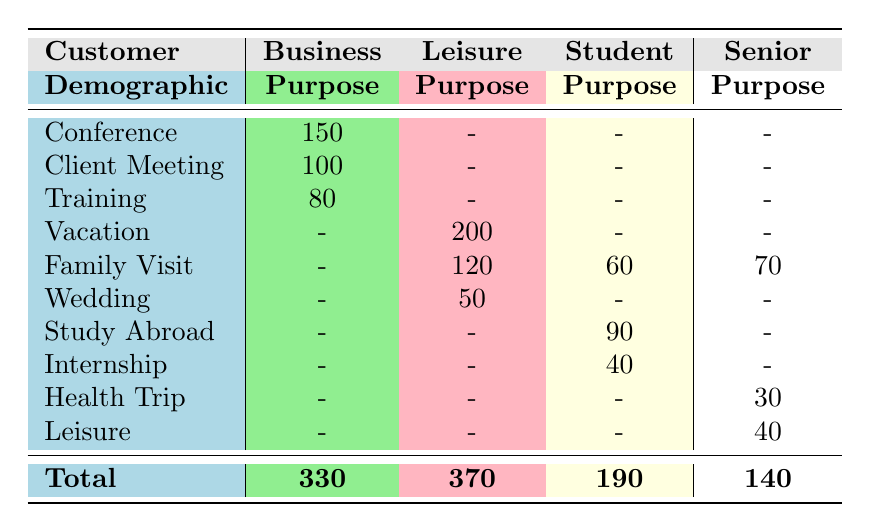What is the total number of flight bookings for Business customers? To find the total for Business customers, sum the counts listed under Business purpose: 150 (Conference) + 100 (Client Meeting) + 80 (Training) = 330.
Answer: 330 How many flight bookings were made for Family Visits across all customer demographics? The counts for Family Visit are: 120 (Leisure) + 60 (Student) + 70 (Senior) = 250.
Answer: 250 Is there any flight booking for the Training purpose by Leisure customers? The table shows that there are no entries for Leisure customers under the Training purpose, indicating that the answer is false.
Answer: No Which customer demographic has the highest total bookings? The totals from the table are 330 for Business, 370 for Leisure, 190 for Student, and 140 for Senior. Hence, Leisure has the highest total bookings.
Answer: Leisure What is the average number of bookings for Student customers based on the table data? To get the average, sum the counts for Student customers: 90 (Study Abroad) + 40 (Internship) + 60 (Family Visit) = 190. Then divide by the number of entries (3) to get 190 / 3 = approximately 63.33.
Answer: 63.33 Are there more Leisure bookings for Vacation than for all other purposes combined? Comparing values, there are 200 bookings for Vacation. For other Leisure purposes: Family Visit (120) + Wedding (50) = 170. Since 200 > 170, the statement is true.
Answer: Yes How many total flight bookings were recorded for Senior customers? The counts for Senior customers are: 70 (Family Visit) + 30 (Health Trip) + 40 (Leisure) = 140.
Answer: 140 Which travel purpose had the least number of bookings for Business customers? Among the listed purposes for Business, the counts are: 150 (Conference), 100 (Client Meeting), and 80 (Training). The least is Training with 80 bookings.
Answer: Training Is it true that no Business customer booked flights for Leisure purposes? Based on the table, Business customer bookings do not have any entries for Leisure purposes, confirming that the statement is true.
Answer: Yes 